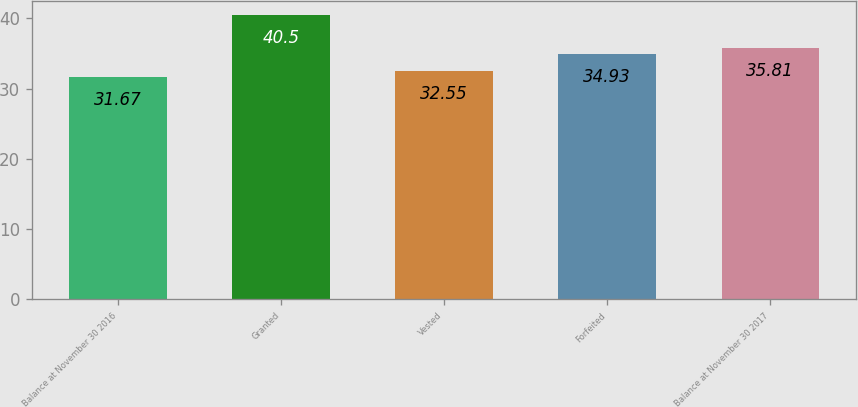<chart> <loc_0><loc_0><loc_500><loc_500><bar_chart><fcel>Balance at November 30 2016<fcel>Granted<fcel>Vested<fcel>Forfeited<fcel>Balance at November 30 2017<nl><fcel>31.67<fcel>40.5<fcel>32.55<fcel>34.93<fcel>35.81<nl></chart> 